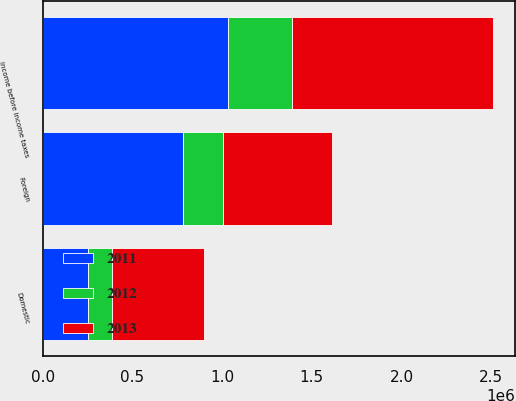<chart> <loc_0><loc_0><loc_500><loc_500><stacked_bar_chart><ecel><fcel>Domestic<fcel>Foreign<fcel>Income before income taxes<nl><fcel>2012<fcel>132916<fcel>223225<fcel>356141<nl><fcel>2013<fcel>512987<fcel>605807<fcel>1.11879e+06<nl><fcel>2011<fcel>252476<fcel>782754<fcel>1.03523e+06<nl></chart> 